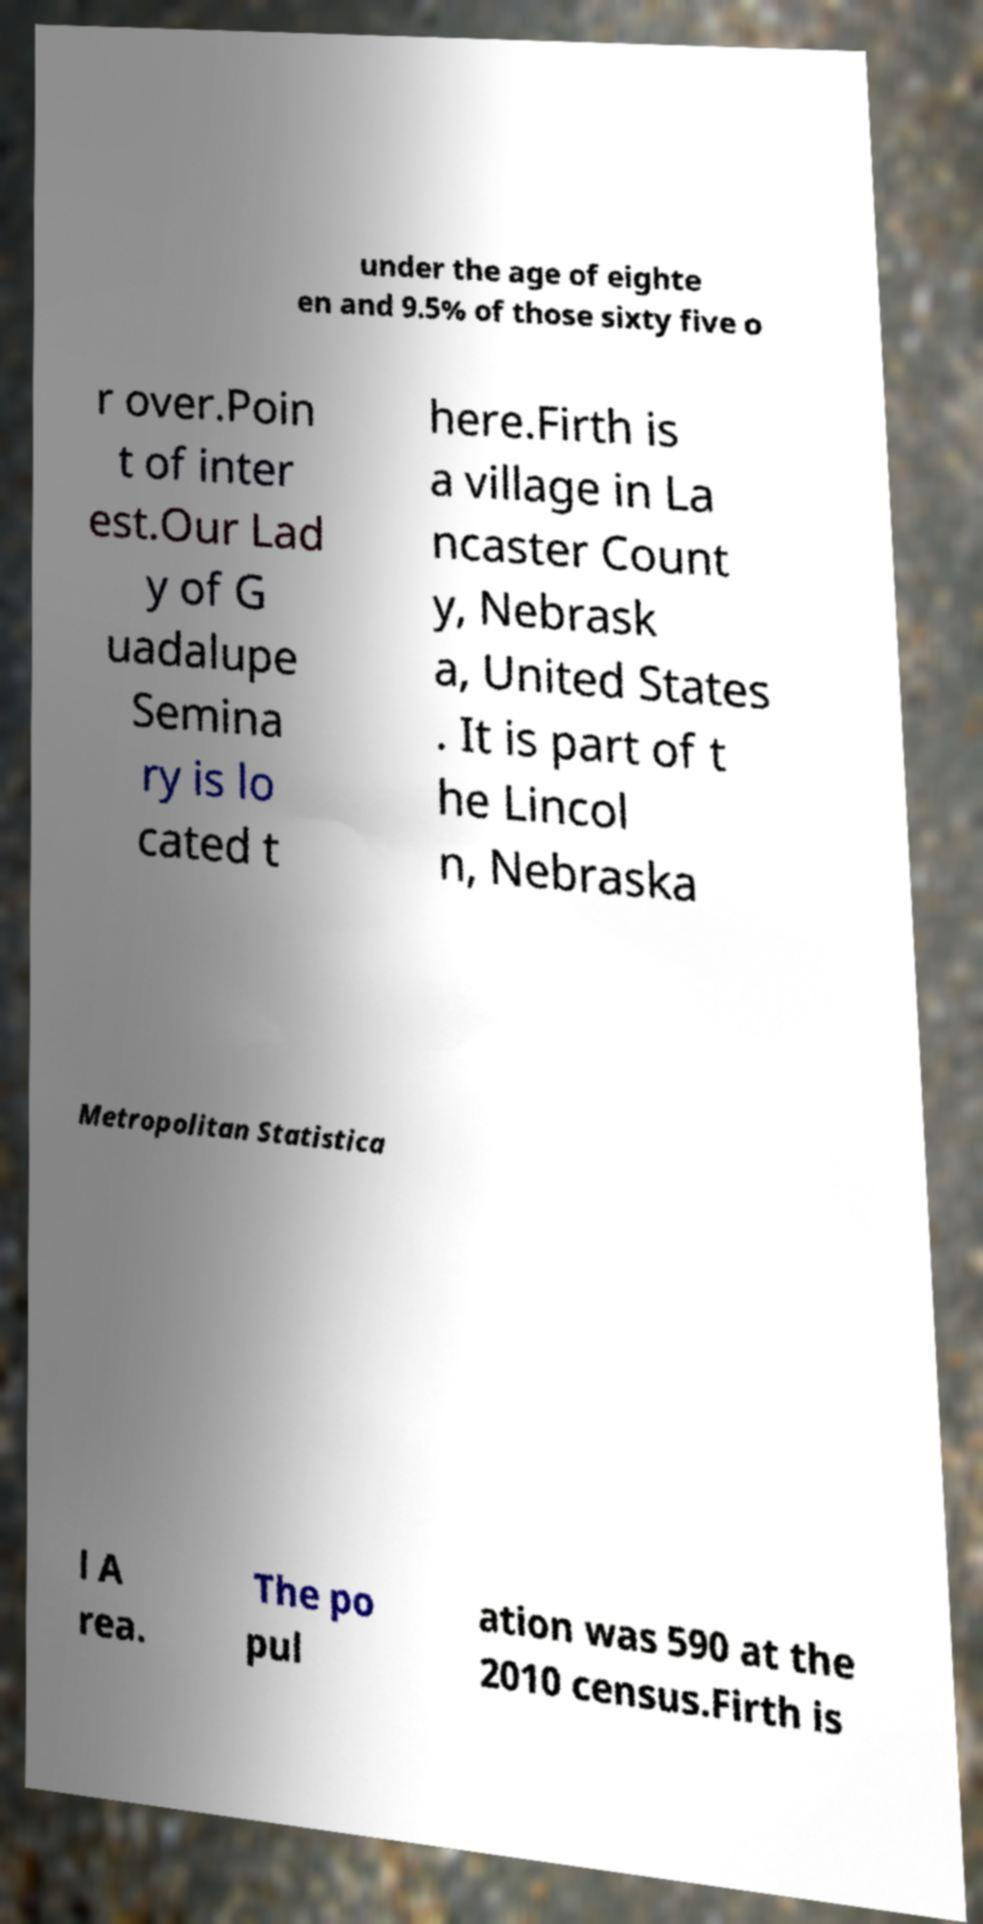What messages or text are displayed in this image? I need them in a readable, typed format. under the age of eighte en and 9.5% of those sixty five o r over.Poin t of inter est.Our Lad y of G uadalupe Semina ry is lo cated t here.Firth is a village in La ncaster Count y, Nebrask a, United States . It is part of t he Lincol n, Nebraska Metropolitan Statistica l A rea. The po pul ation was 590 at the 2010 census.Firth is 